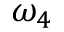Convert formula to latex. <formula><loc_0><loc_0><loc_500><loc_500>\omega _ { 4 }</formula> 